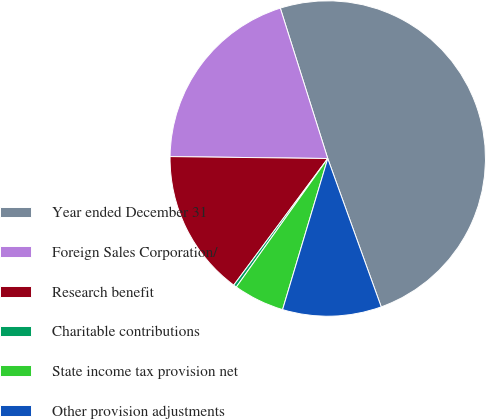Convert chart to OTSL. <chart><loc_0><loc_0><loc_500><loc_500><pie_chart><fcel>Year ended December 31<fcel>Foreign Sales Corporation/<fcel>Research benefit<fcel>Charitable contributions<fcel>State income tax provision net<fcel>Other provision adjustments<nl><fcel>49.36%<fcel>19.94%<fcel>15.03%<fcel>0.32%<fcel>5.22%<fcel>10.13%<nl></chart> 